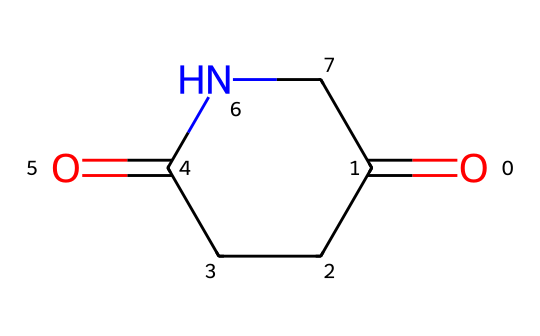What is the molecular formula of glutarimide? The molecular formula can be found by identifying the number of each type of atom present in the SMILES representation. Analyzing the structure, it contains 5 carbon atoms (C), 7 hydrogen atoms (H), 2 oxygen atoms (O), and 1 nitrogen atom (N). Combining these gives the molecular formula C5H7N1O2.
Answer: C5H7NO2 How many rings does glutarimide have? By observing the structure provided in the SMILES, it is evident that the chemical contains one ring structure indicated by the number '1' which signifies where the carbon atoms are connected to form a cyclic compound.
Answer: 1 What type of functional groups are present in glutarimide? The structure includes both carbonyl groups (indicated by C=O) and an imide group (the characteristic N-C=O structure). Therefore, the functional groups present are carbonyl and imide functional groups.
Answer: carbonyl and imide What is the hybridization of the nitrogen atom in glutarimide? To determine the hybridization of nitrogen, you consider its bonding in the cyclic structure. The nitrogen is bonded to one carbon and has a lone pair, leading to a trigonal planar configuration around the nitrogen atom, suggesting sp2 hybridization.
Answer: sp2 What geometric shape characterizes the deterioration of glutarimide? Analyzing the molecular geometry around the nitrogen and the adjacent carbon atoms reveals that the nitrogen and carbon atoms are likely configured in a planar geometry due to sp2 hybridization, leading to a roughly planar shape for the entirety of glutarimide as a molecule.
Answer: planar How does the presence of carbonyl groups affect the conformational stability of glutarimide? The carbonyl groups contribute to polar interactions within the molecule and can introduce dipole-dipole interactions, thus enhancing stability. However, their position also might lead to steric interactions depending on the conformation, which can affect overall stability variations between different conformers, suggesting an intricate relationship.
Answer: enhances stability 